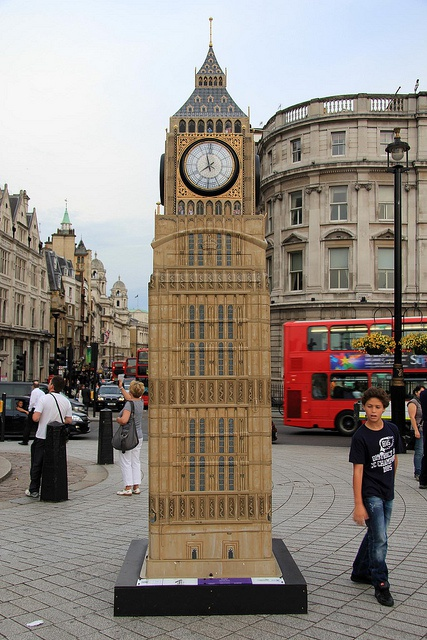Describe the objects in this image and their specific colors. I can see bus in lavender, black, brown, gray, and maroon tones, people in lavender, black, brown, and gray tones, people in lavender, gray, black, darkgray, and lightgray tones, people in lavender, black, lightgray, darkgray, and gray tones, and clock in lavender, darkgray, lightgray, gray, and tan tones in this image. 